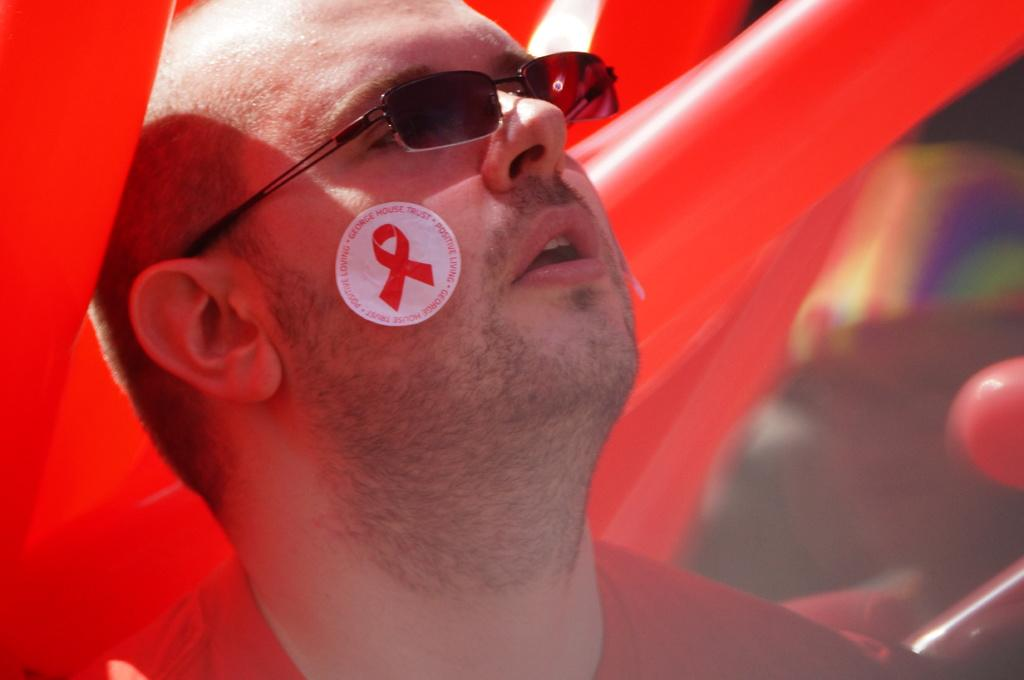Who is in the image? There is a person in the image. What is the person wearing? The person is wearing a red dress and goggles. What color are the balloons in the background? The balloons in the background are red. How would you describe the background of the image? The background of the image is blurred. How many cherries can be seen in the person's hand in the image? There are no cherries present in the image. Is there a frame around the person in the image? The image does not show a frame around the person. 